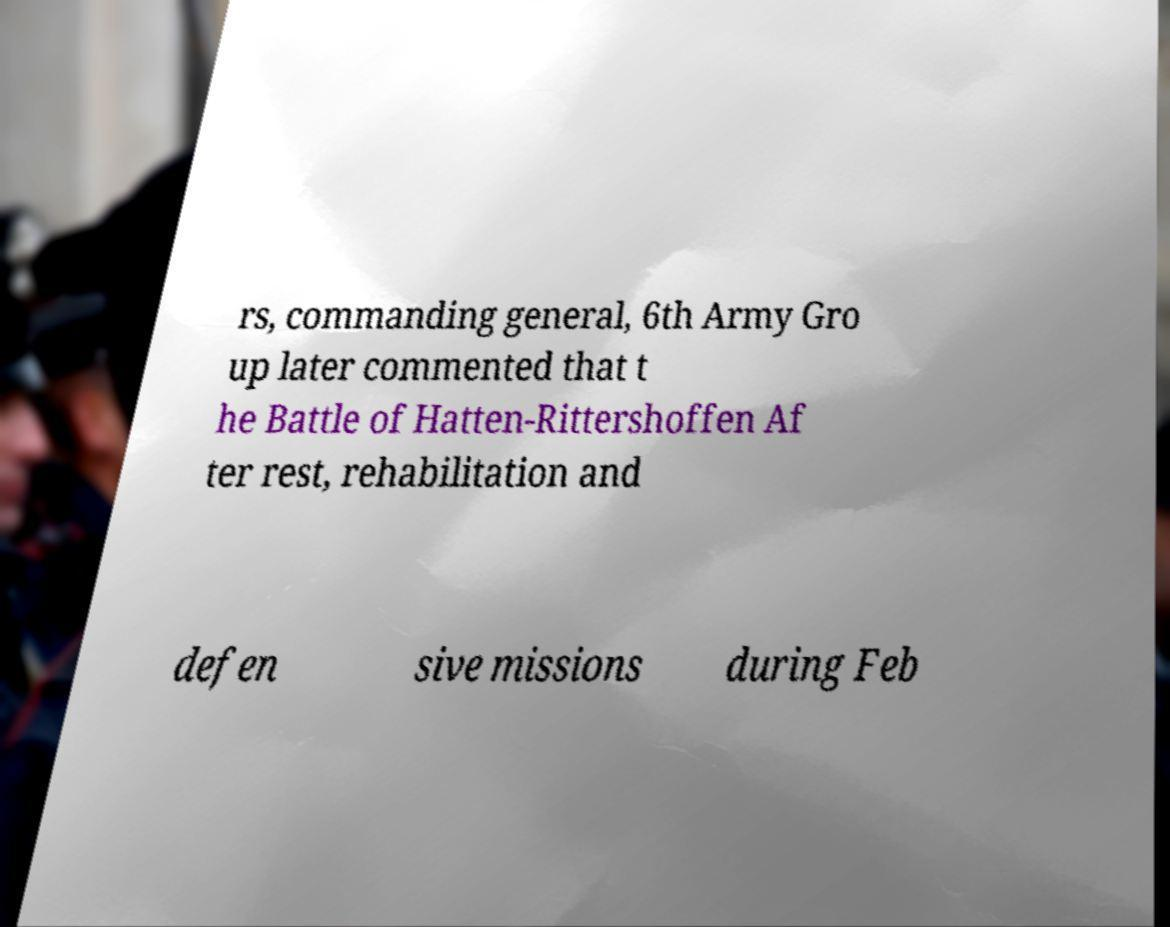Can you accurately transcribe the text from the provided image for me? rs, commanding general, 6th Army Gro up later commented that t he Battle of Hatten-Rittershoffen Af ter rest, rehabilitation and defen sive missions during Feb 